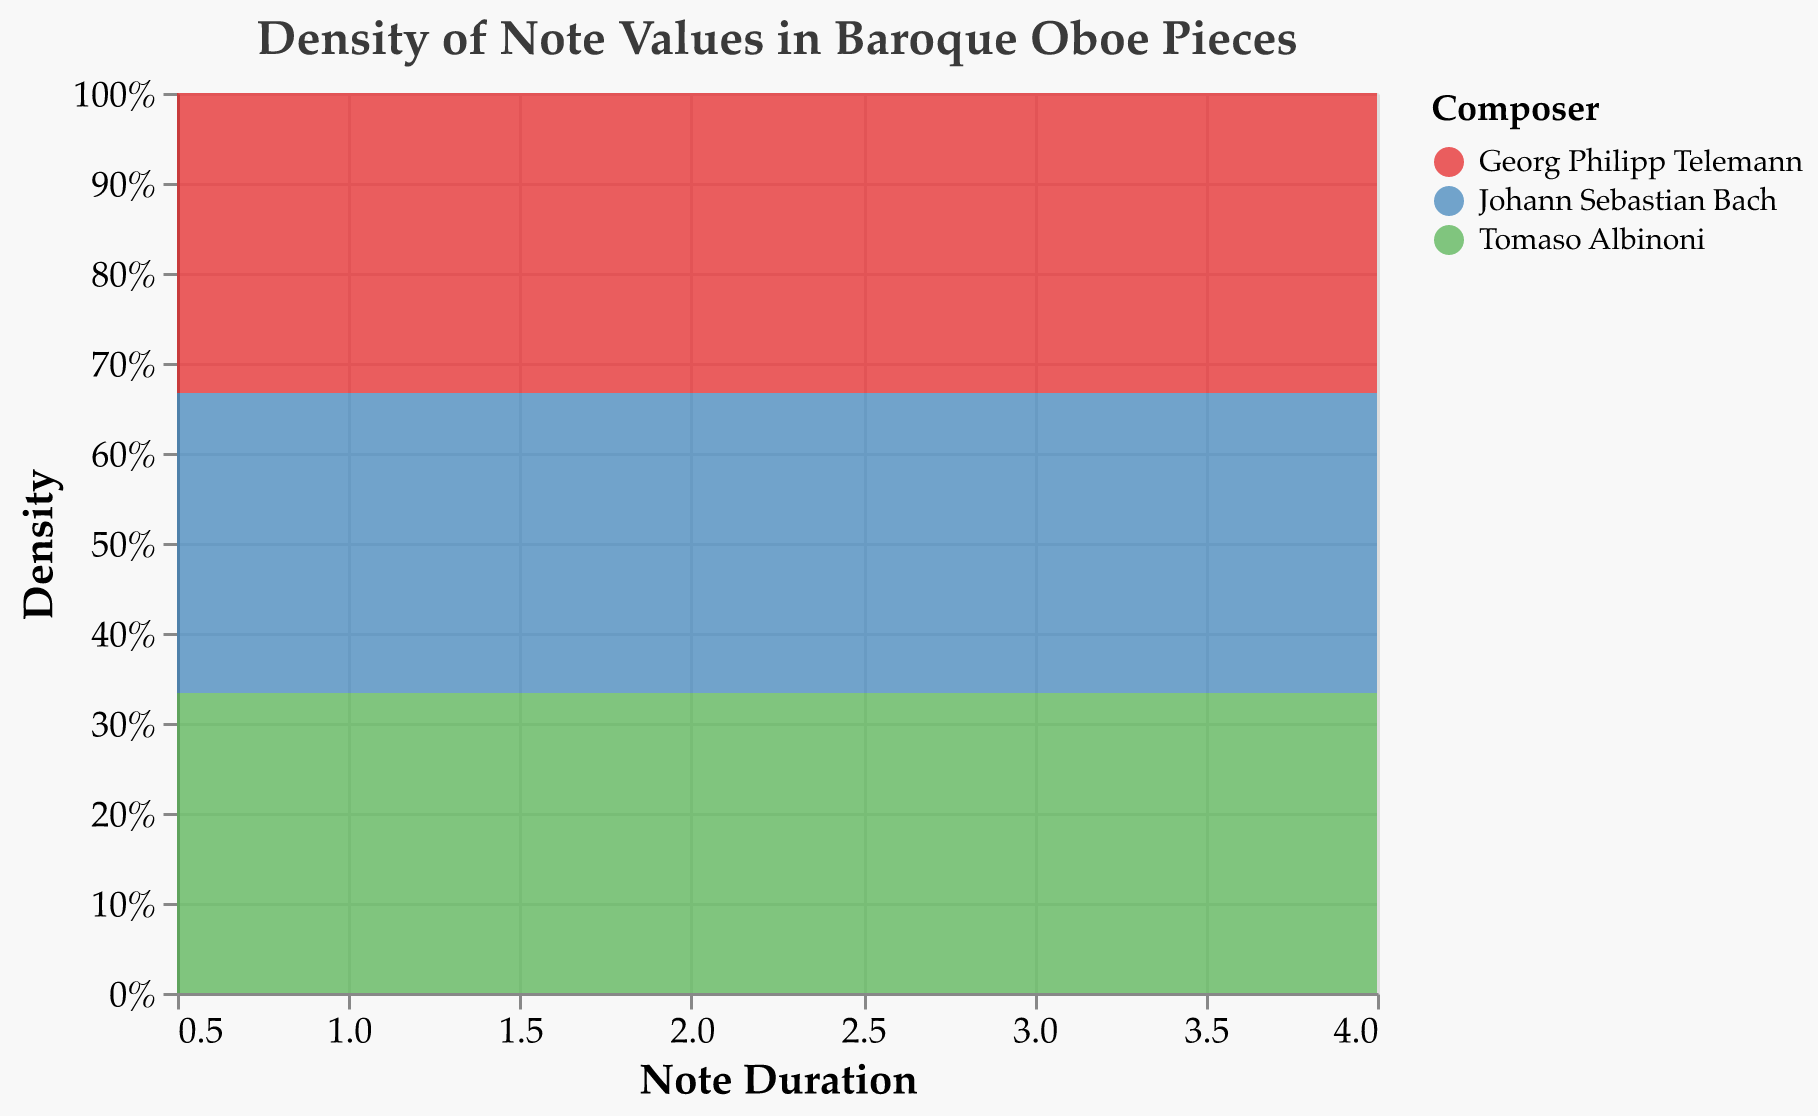What is the title of the figure? The title is written at the top of the density plot. It mentions the plot's focus, which is the "Density of Note Values in Baroque Oboe Pieces."
Answer: Density of Note Values in Baroque Oboe Pieces Which composer has the highest density for the eighth note value? By identifying the eighth note value on the x-axis and looking up vertically to see the normalized density distribution, the color-code corresponding to "Georg Philipp Telemann" is at the highest peak.
Answer: Georg Philipp Telemann What is the duration range for the notes analyzed in this plot? The x-axis shows the range of note durations included in the analysis, which starts from 0.5 (eighth note) and goes up to 4.0 (whole note).
Answer: 0.5 to 4.0 Which note value has the highest overall density regardless of composer? By observing the highest peaks in the density plot along the y-axis, the whole note value shows the highest peaks within the visual density plot.
Answer: Whole Which composer's note distributions are represented by the color blue? In the legend of the density plot, the composer "Johann Sebastian Bach" is represented by the color blue.
Answer: Johann Sebastian Bach How do the density distributions of half notes compare between Bach and Telemann? By locating the half note duration on the x-axis and comparing the heights of the corresponding density peaks for blue (Bach) and green (Telemann), we can determine which has a higher density. Telemann has a slightly higher normalized density compared to Bach.
Answer: Telemann has a higher density What is the density distribution trend for Tomaso Albinoni? Observing the areas under the curve for Tomaso Albinoni (red) reveals that his note values maintain almost equal density distribution, implying an even usage of various note values throughout his compositions.
Answer: Even distribution What is the density of quarter notes for Johann Sebastian Bach relative to other composers? Identifying the quarter note duration on the x-axis, comparing the density peaks reveals Johann Sebastian Bach (blue) having a lower peak compared to both Georg Philipp Telemann (green) and Tomaso Albinoni (red).
Answer: Lower than Telemann and Albinoni How does the density of whole notes compare among all three composers? By looking at the whole note duration on the x-axis and comparing the heights of the density peaks: Telemann (green) and Albinoni (red) have higher peaks than Bach (blue).
Answer: Telemann = Albinoni > Bach 